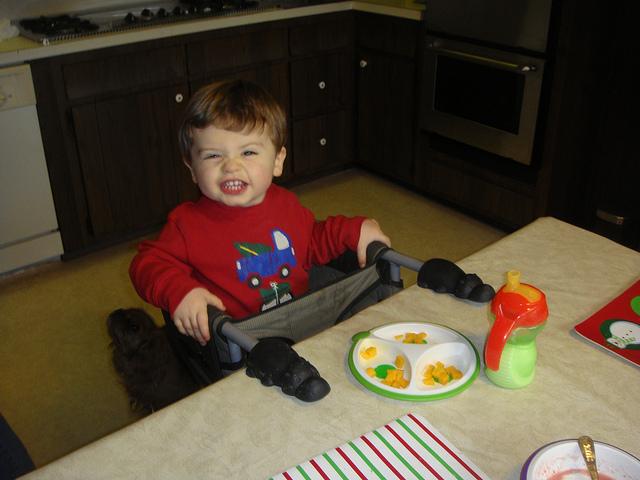What room is this?
Give a very brief answer. Kitchen. What color is the baby's shirt?
Keep it brief. Red. What kind of meat is being served?
Keep it brief. No meat. What color is the napkin?
Quick response, please. Stripe. Is this an old person?
Give a very brief answer. No. What is on the boys shirt?
Be succinct. Truck. 